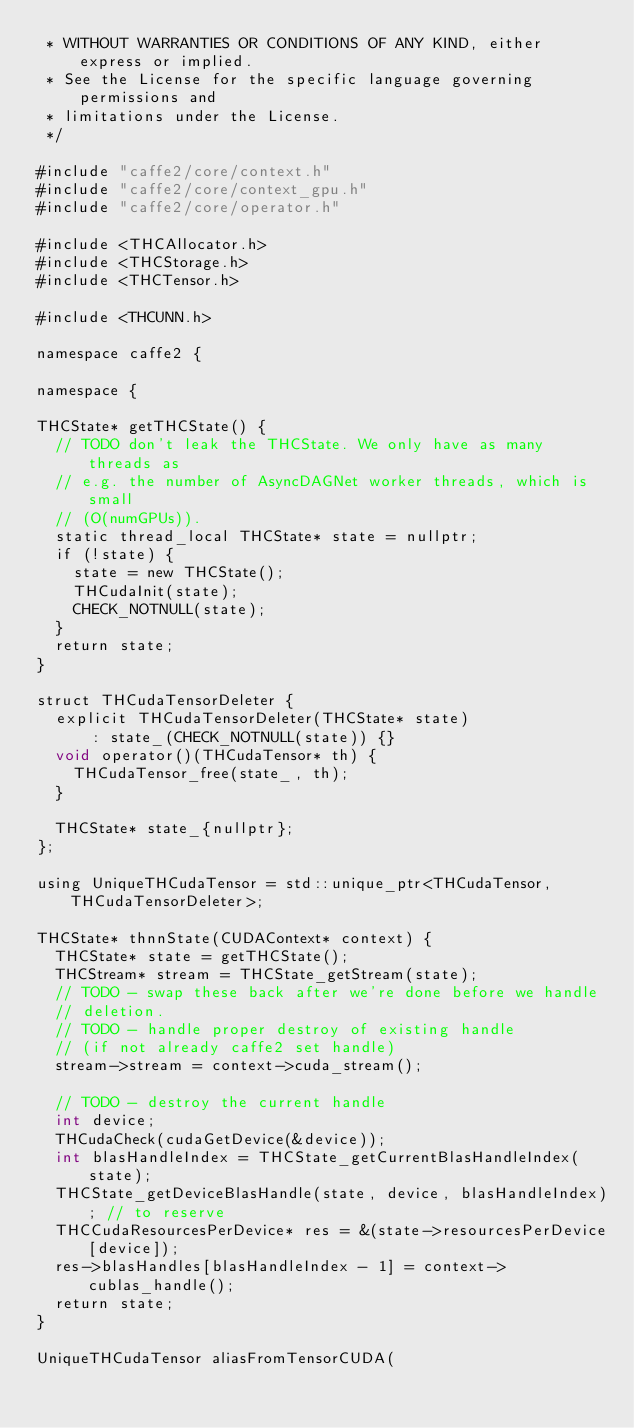Convert code to text. <code><loc_0><loc_0><loc_500><loc_500><_Cuda_> * WITHOUT WARRANTIES OR CONDITIONS OF ANY KIND, either express or implied.
 * See the License for the specific language governing permissions and
 * limitations under the License.
 */

#include "caffe2/core/context.h"
#include "caffe2/core/context_gpu.h"
#include "caffe2/core/operator.h"

#include <THCAllocator.h>
#include <THCStorage.h>
#include <THCTensor.h>

#include <THCUNN.h>

namespace caffe2 {

namespace {

THCState* getTHCState() {
  // TODO don't leak the THCState. We only have as many threads as
  // e.g. the number of AsyncDAGNet worker threads, which is small
  // (O(numGPUs)).
  static thread_local THCState* state = nullptr;
  if (!state) {
    state = new THCState();
    THCudaInit(state);
    CHECK_NOTNULL(state);
  }
  return state;
}

struct THCudaTensorDeleter {
  explicit THCudaTensorDeleter(THCState* state)
      : state_(CHECK_NOTNULL(state)) {}
  void operator()(THCudaTensor* th) {
    THCudaTensor_free(state_, th);
  }

  THCState* state_{nullptr};
};

using UniqueTHCudaTensor = std::unique_ptr<THCudaTensor, THCudaTensorDeleter>;

THCState* thnnState(CUDAContext* context) {
  THCState* state = getTHCState();
  THCStream* stream = THCState_getStream(state);
  // TODO - swap these back after we're done before we handle
  // deletion.
  // TODO - handle proper destroy of existing handle
  // (if not already caffe2 set handle)
  stream->stream = context->cuda_stream();

  // TODO - destroy the current handle
  int device;
  THCudaCheck(cudaGetDevice(&device));
  int blasHandleIndex = THCState_getCurrentBlasHandleIndex(state);
  THCState_getDeviceBlasHandle(state, device, blasHandleIndex); // to reserve
  THCCudaResourcesPerDevice* res = &(state->resourcesPerDevice[device]);
  res->blasHandles[blasHandleIndex - 1] = context->cublas_handle();
  return state;
}

UniqueTHCudaTensor aliasFromTensorCUDA(</code> 